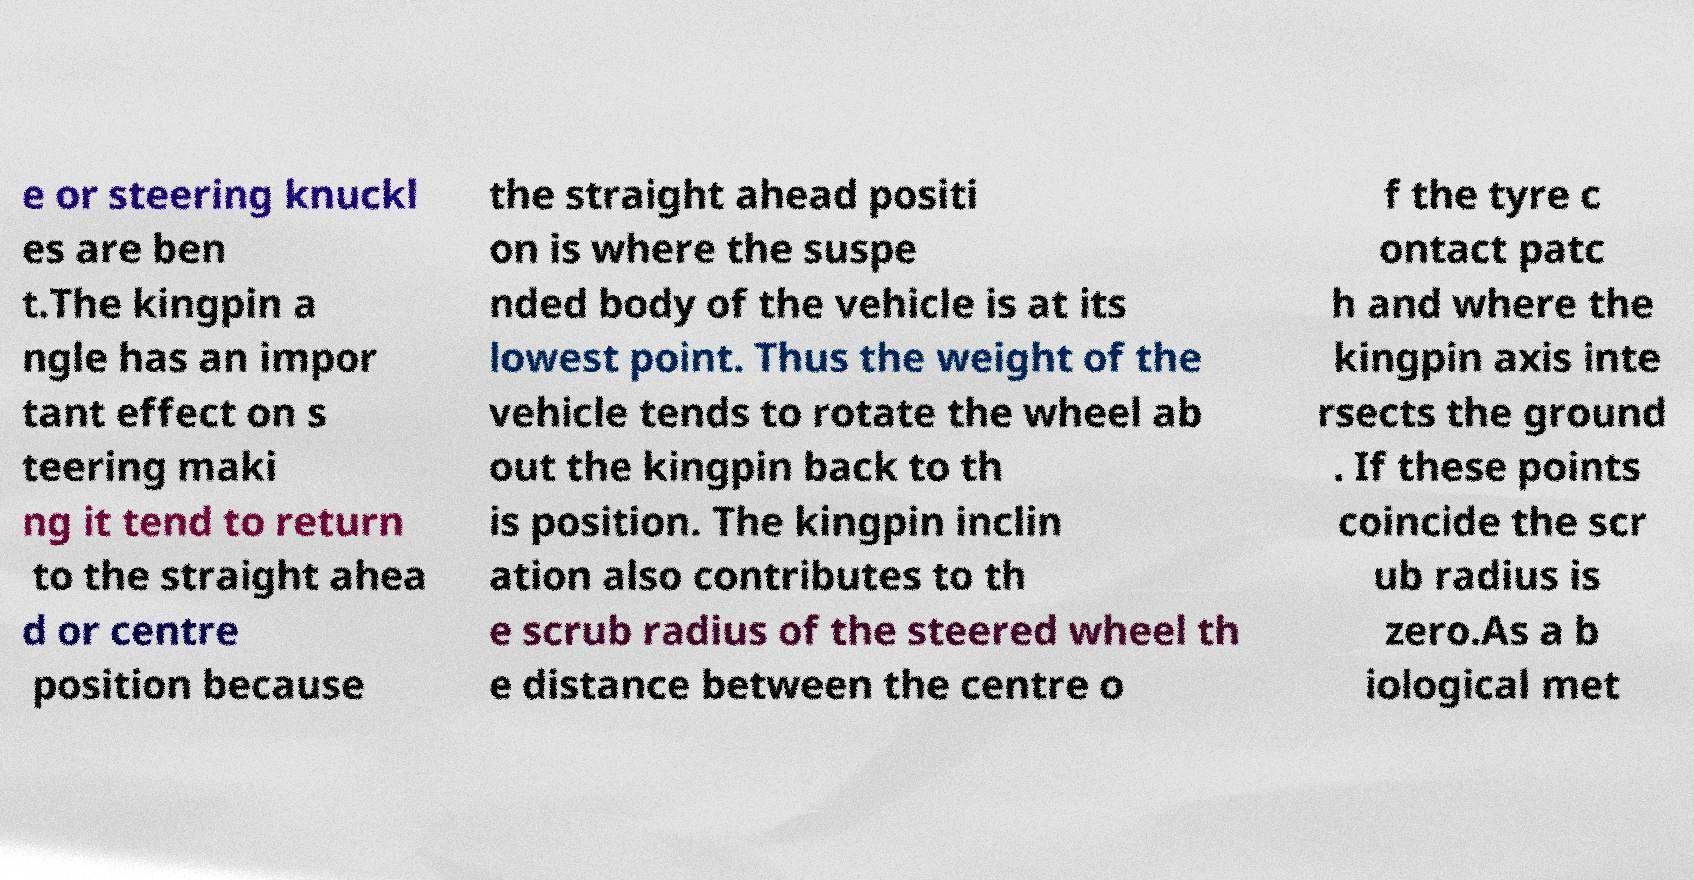I need the written content from this picture converted into text. Can you do that? e or steering knuckl es are ben t.The kingpin a ngle has an impor tant effect on s teering maki ng it tend to return to the straight ahea d or centre position because the straight ahead positi on is where the suspe nded body of the vehicle is at its lowest point. Thus the weight of the vehicle tends to rotate the wheel ab out the kingpin back to th is position. The kingpin inclin ation also contributes to th e scrub radius of the steered wheel th e distance between the centre o f the tyre c ontact patc h and where the kingpin axis inte rsects the ground . If these points coincide the scr ub radius is zero.As a b iological met 